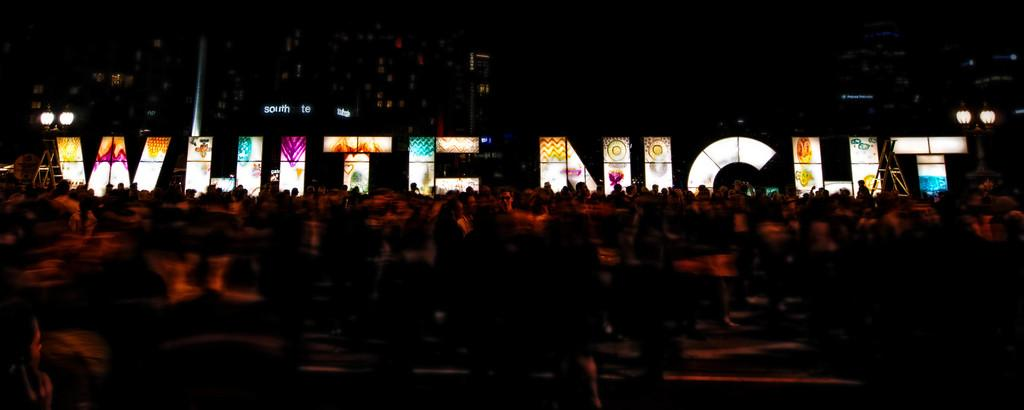What is unique about the lights in the image? The lights are attached to letters in the image. Who or what can be seen in the image besides the lights? There are people in the image. What can be seen in the distance behind the people and lights? There are buildings in the background of the image. What type of fork is being used to stir the pan in the image? There is no fork or pan present in the image; it features lights attached to letters and people in front of buildings. 